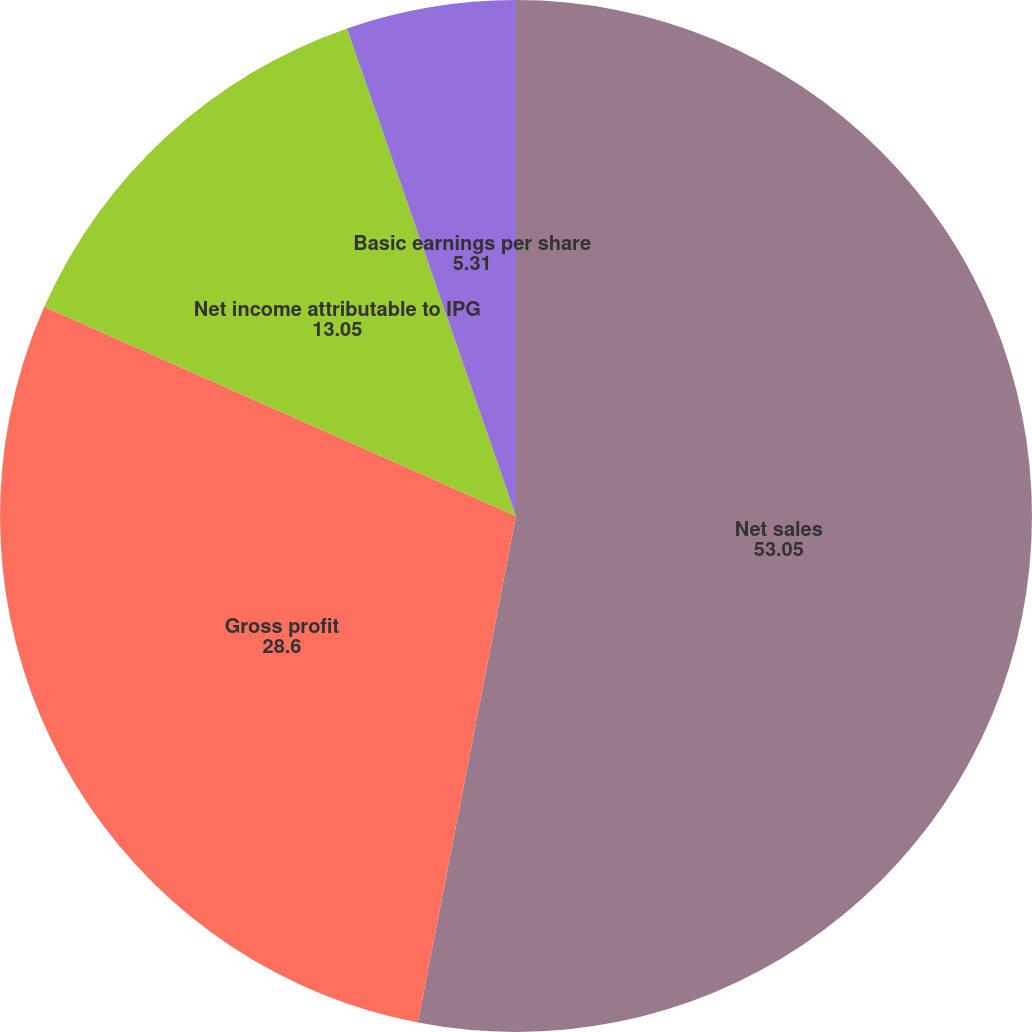<chart> <loc_0><loc_0><loc_500><loc_500><pie_chart><fcel>Net sales<fcel>Gross profit<fcel>Net income attributable to IPG<fcel>Basic earnings per share<fcel>Diluted earnings per share<nl><fcel>53.05%<fcel>28.6%<fcel>13.05%<fcel>5.31%<fcel>0.0%<nl></chart> 